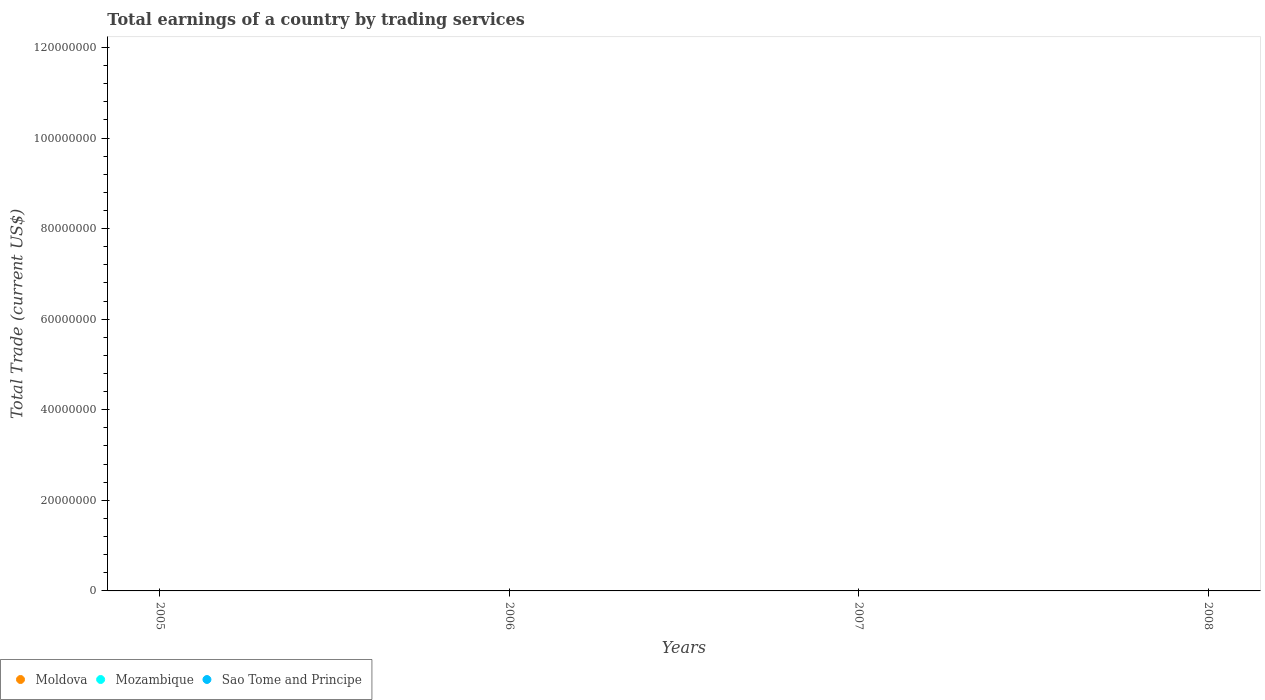How many different coloured dotlines are there?
Provide a short and direct response. 0. Is the number of dotlines equal to the number of legend labels?
Offer a very short reply. No. Across all years, what is the minimum total earnings in Mozambique?
Provide a short and direct response. 0. What is the total total earnings in Moldova in the graph?
Offer a terse response. 0. What is the difference between the total earnings in Sao Tome and Principe in 2005 and the total earnings in Moldova in 2008?
Your answer should be very brief. 0. What is the average total earnings in Mozambique per year?
Your answer should be compact. 0. In how many years, is the total earnings in Mozambique greater than the average total earnings in Mozambique taken over all years?
Give a very brief answer. 0. Is it the case that in every year, the sum of the total earnings in Mozambique and total earnings in Moldova  is greater than the total earnings in Sao Tome and Principe?
Provide a short and direct response. No. Does the total earnings in Sao Tome and Principe monotonically increase over the years?
Your response must be concise. No. Is the total earnings in Moldova strictly less than the total earnings in Mozambique over the years?
Provide a short and direct response. Yes. What is the difference between two consecutive major ticks on the Y-axis?
Offer a terse response. 2.00e+07. Are the values on the major ticks of Y-axis written in scientific E-notation?
Provide a short and direct response. No. Does the graph contain any zero values?
Provide a succinct answer. Yes. Where does the legend appear in the graph?
Your answer should be compact. Bottom left. How many legend labels are there?
Offer a very short reply. 3. How are the legend labels stacked?
Your response must be concise. Horizontal. What is the title of the graph?
Provide a short and direct response. Total earnings of a country by trading services. What is the label or title of the X-axis?
Give a very brief answer. Years. What is the label or title of the Y-axis?
Ensure brevity in your answer.  Total Trade (current US$). What is the Total Trade (current US$) in Mozambique in 2005?
Make the answer very short. 0. What is the Total Trade (current US$) in Mozambique in 2006?
Keep it short and to the point. 0. What is the Total Trade (current US$) of Sao Tome and Principe in 2006?
Offer a very short reply. 0. What is the Total Trade (current US$) of Moldova in 2007?
Ensure brevity in your answer.  0. What is the Total Trade (current US$) of Mozambique in 2008?
Give a very brief answer. 0. What is the Total Trade (current US$) of Sao Tome and Principe in 2008?
Ensure brevity in your answer.  0. What is the total Total Trade (current US$) in Mozambique in the graph?
Ensure brevity in your answer.  0. What is the total Total Trade (current US$) of Sao Tome and Principe in the graph?
Your answer should be very brief. 0. What is the average Total Trade (current US$) in Mozambique per year?
Your answer should be very brief. 0. 